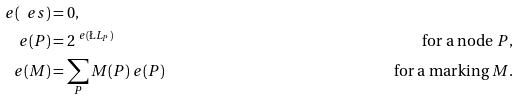Convert formula to latex. <formula><loc_0><loc_0><loc_500><loc_500>\ e ( \ e s ) & = 0 , \\ \ e ( P ) & = 2 ^ { \ e ( \L L _ { P } ) } & \text {for a node $P$} , \\ \ e ( M ) & = \sum _ { P } M ( P ) \ e ( P ) & \text {for a marking $M$} .</formula> 